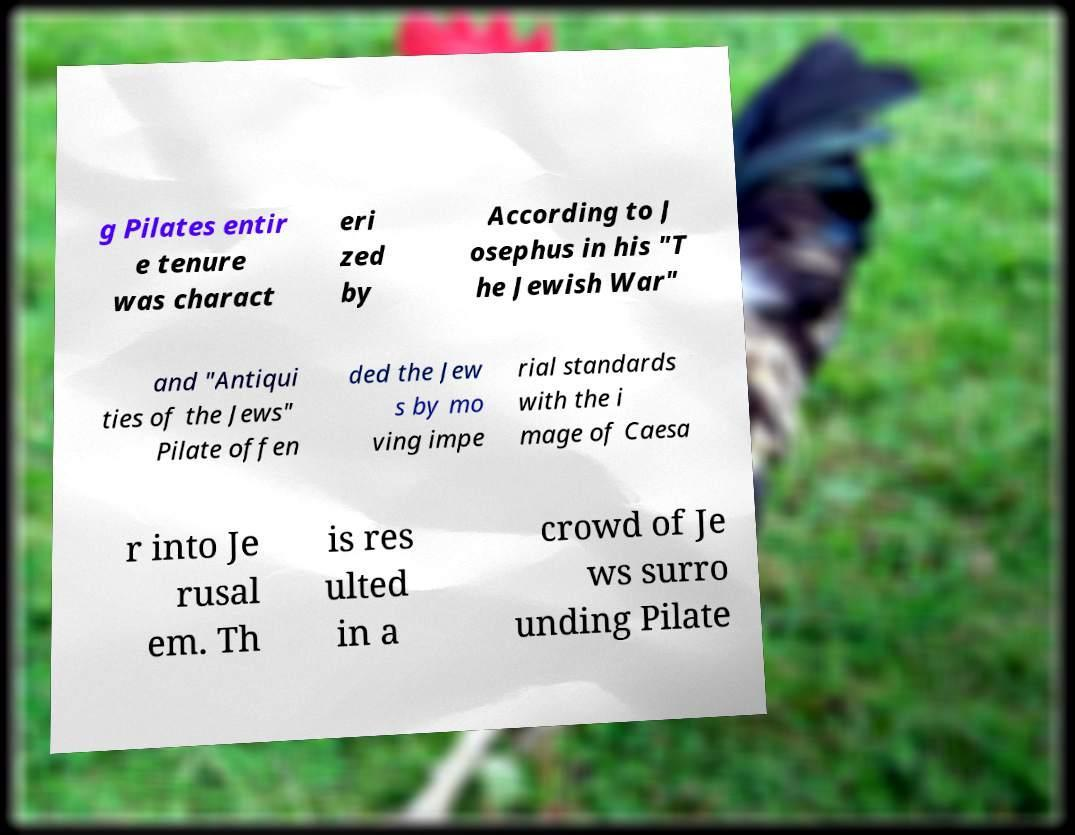Could you extract and type out the text from this image? g Pilates entir e tenure was charact eri zed by According to J osephus in his "T he Jewish War" and "Antiqui ties of the Jews" Pilate offen ded the Jew s by mo ving impe rial standards with the i mage of Caesa r into Je rusal em. Th is res ulted in a crowd of Je ws surro unding Pilate 